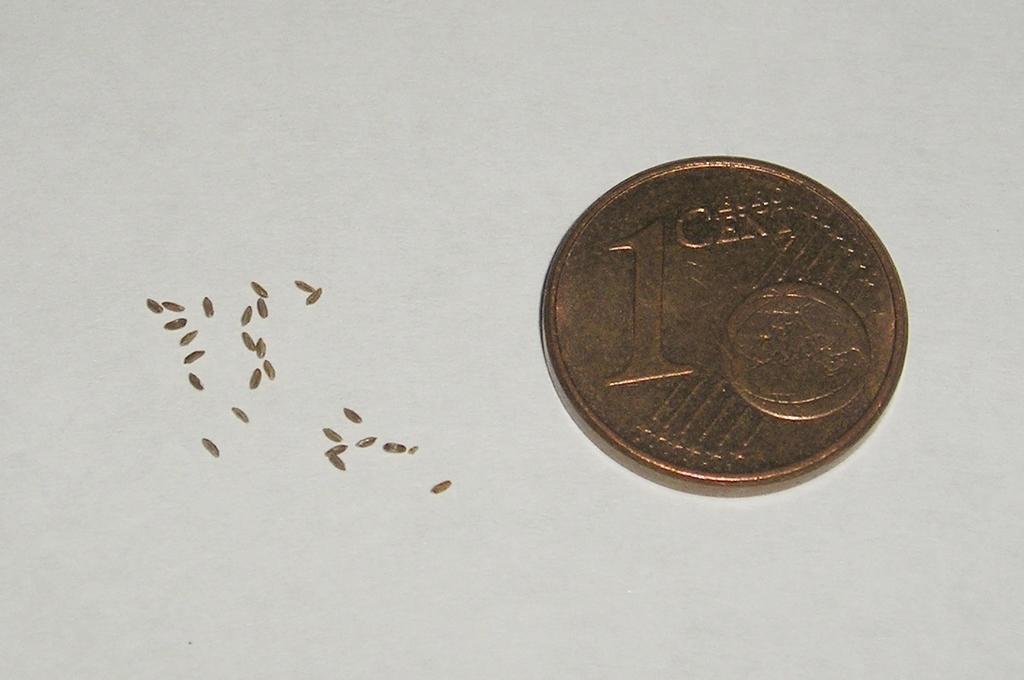What is the value of this coin?
Provide a short and direct response. 1 cent. 